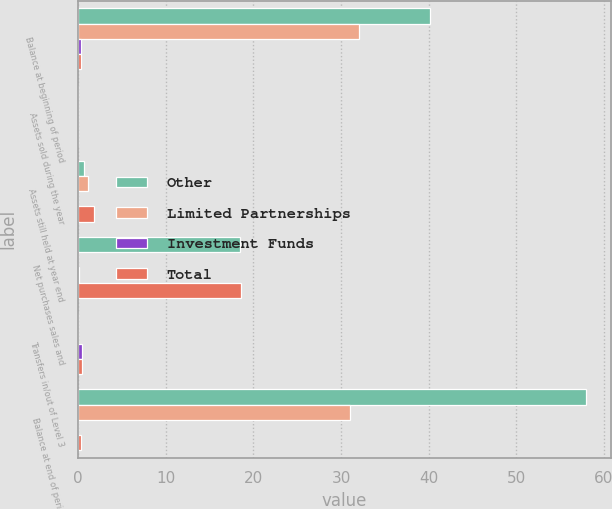Convert chart. <chart><loc_0><loc_0><loc_500><loc_500><stacked_bar_chart><ecel><fcel>Balance at beginning of period<fcel>Assets sold during the year<fcel>Assets still held at year end<fcel>Net purchases sales and<fcel>Transfers in/out of Level 3<fcel>Balance at end of period<nl><fcel>Other<fcel>40.1<fcel>0<fcel>0.7<fcel>18.5<fcel>0<fcel>57.9<nl><fcel>Limited Partnerships<fcel>32.1<fcel>0<fcel>1.1<fcel>0<fcel>0<fcel>31<nl><fcel>Investment Funds<fcel>0.3<fcel>0<fcel>0<fcel>0.1<fcel>0.4<fcel>0<nl><fcel>Total<fcel>0.35<fcel>0<fcel>1.8<fcel>18.6<fcel>0.4<fcel>0.35<nl></chart> 